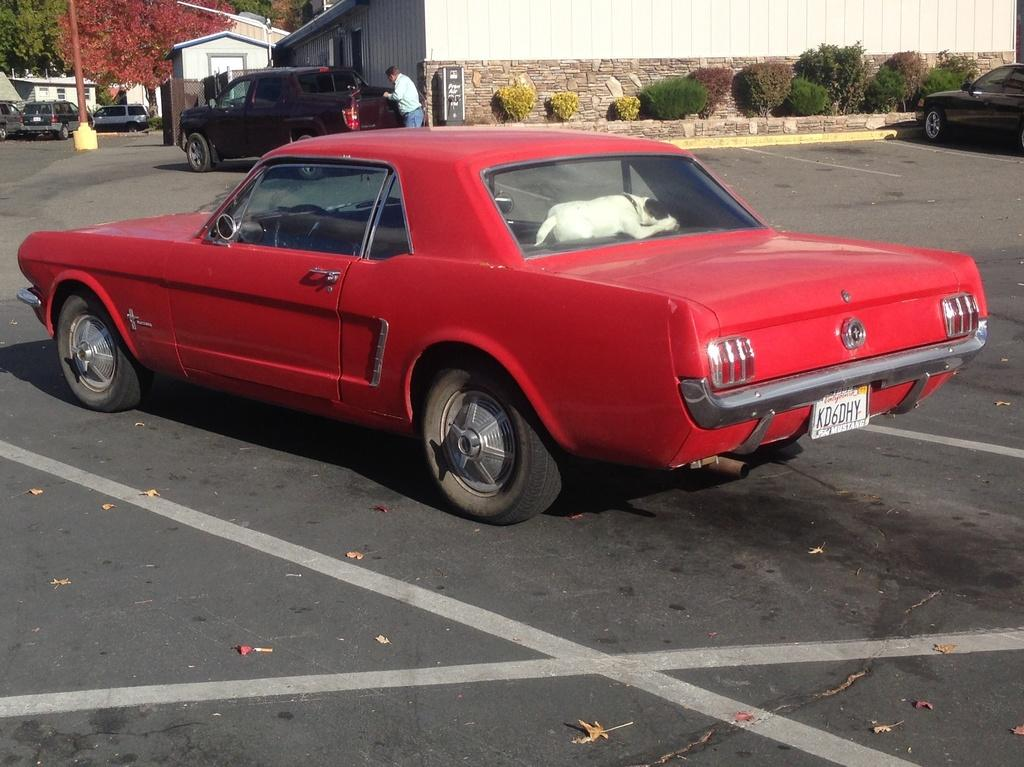What color is the car in the image? The car in the image is red. Where is the car located in the image? The car is parked on the road. What can be seen in the background of the image? In the background of the image, there are cars, plants, houses, trees, and a man. How many cars are visible in the image? There is one car in the foreground and at least one car visible in the background, making a total of at least two cars. What type of sponge is being used to paint the man's house in the image? There is no sponge or painting activity visible in the image. How does the whip affect the car's movement in the image? There is no whip present in the image, and the car is parked, so it is not moving. 